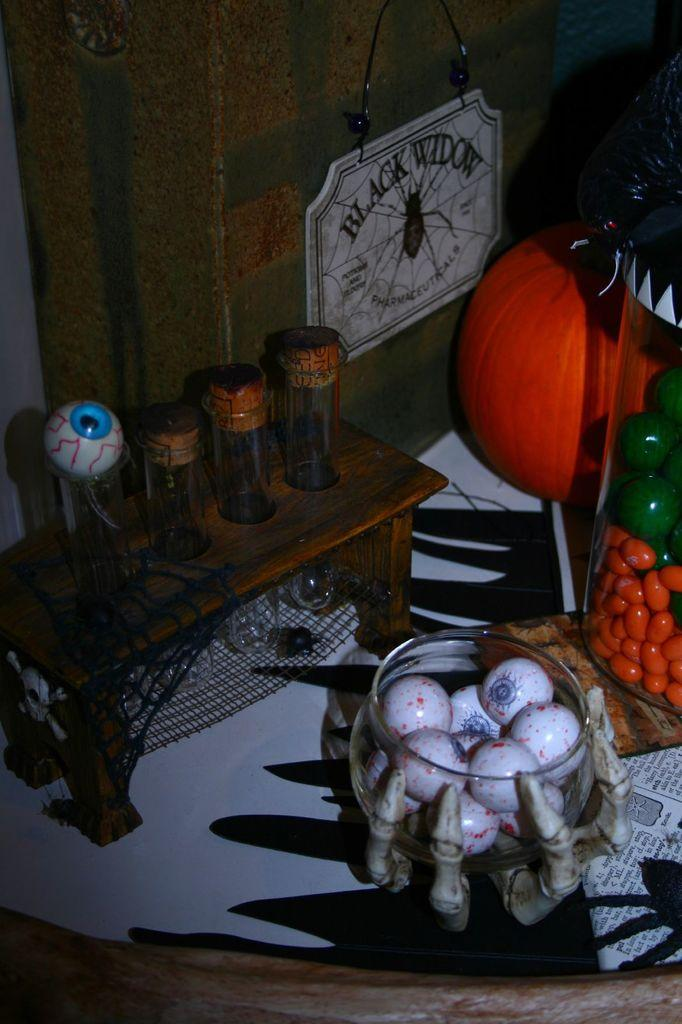What is in the bowl that is visible in the image? The facts provided do not specify what is in the bowl. What is the material of the table in the image? The table in the image is made of wood. How many eyes can be seen on the table in the image? There are no eyes present on the table in the image. What type of trouble is the bowl causing in the image? The facts provided do not indicate any trouble caused by the bowl in the image. 